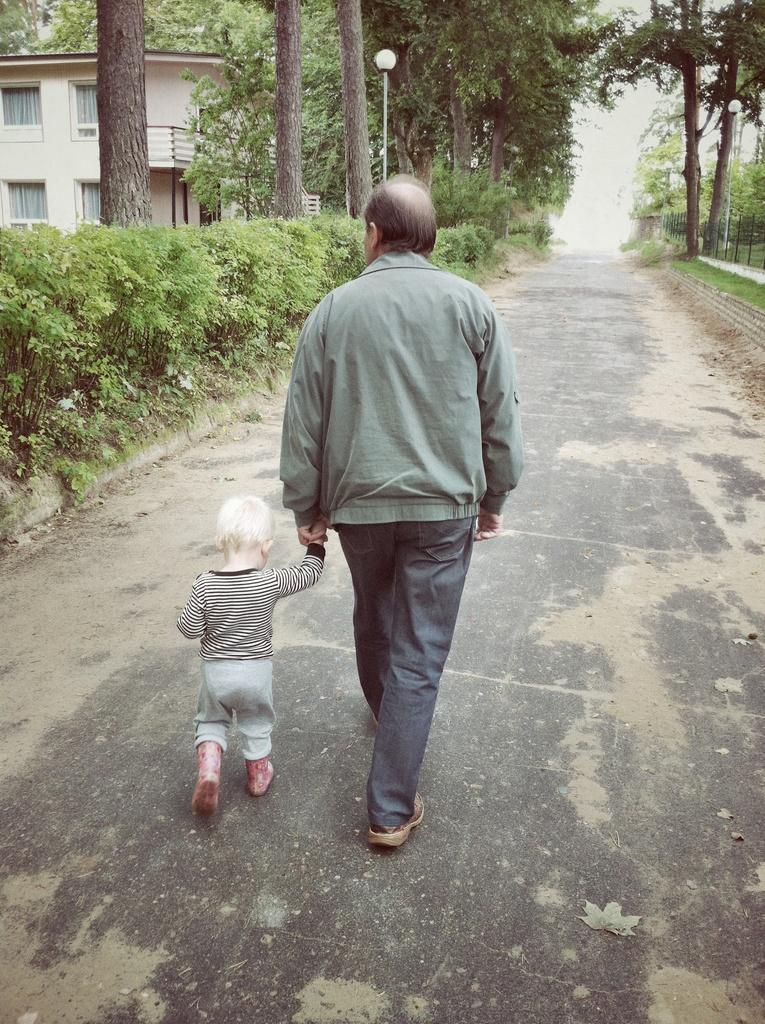Who is present in the image? There is a man and a boy in the image. What are the man and boy doing in the image? The man and boy are walking together in the image. What can be seen in the background of the image? There are plants, trees, and a building visible in the background of the image. Is there a map of the island visible in the image? There is no map or island present in the image. 